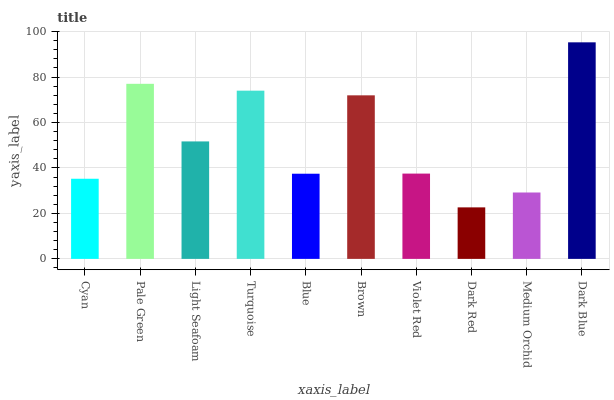Is Dark Red the minimum?
Answer yes or no. Yes. Is Dark Blue the maximum?
Answer yes or no. Yes. Is Pale Green the minimum?
Answer yes or no. No. Is Pale Green the maximum?
Answer yes or no. No. Is Pale Green greater than Cyan?
Answer yes or no. Yes. Is Cyan less than Pale Green?
Answer yes or no. Yes. Is Cyan greater than Pale Green?
Answer yes or no. No. Is Pale Green less than Cyan?
Answer yes or no. No. Is Light Seafoam the high median?
Answer yes or no. Yes. Is Violet Red the low median?
Answer yes or no. Yes. Is Pale Green the high median?
Answer yes or no. No. Is Dark Red the low median?
Answer yes or no. No. 